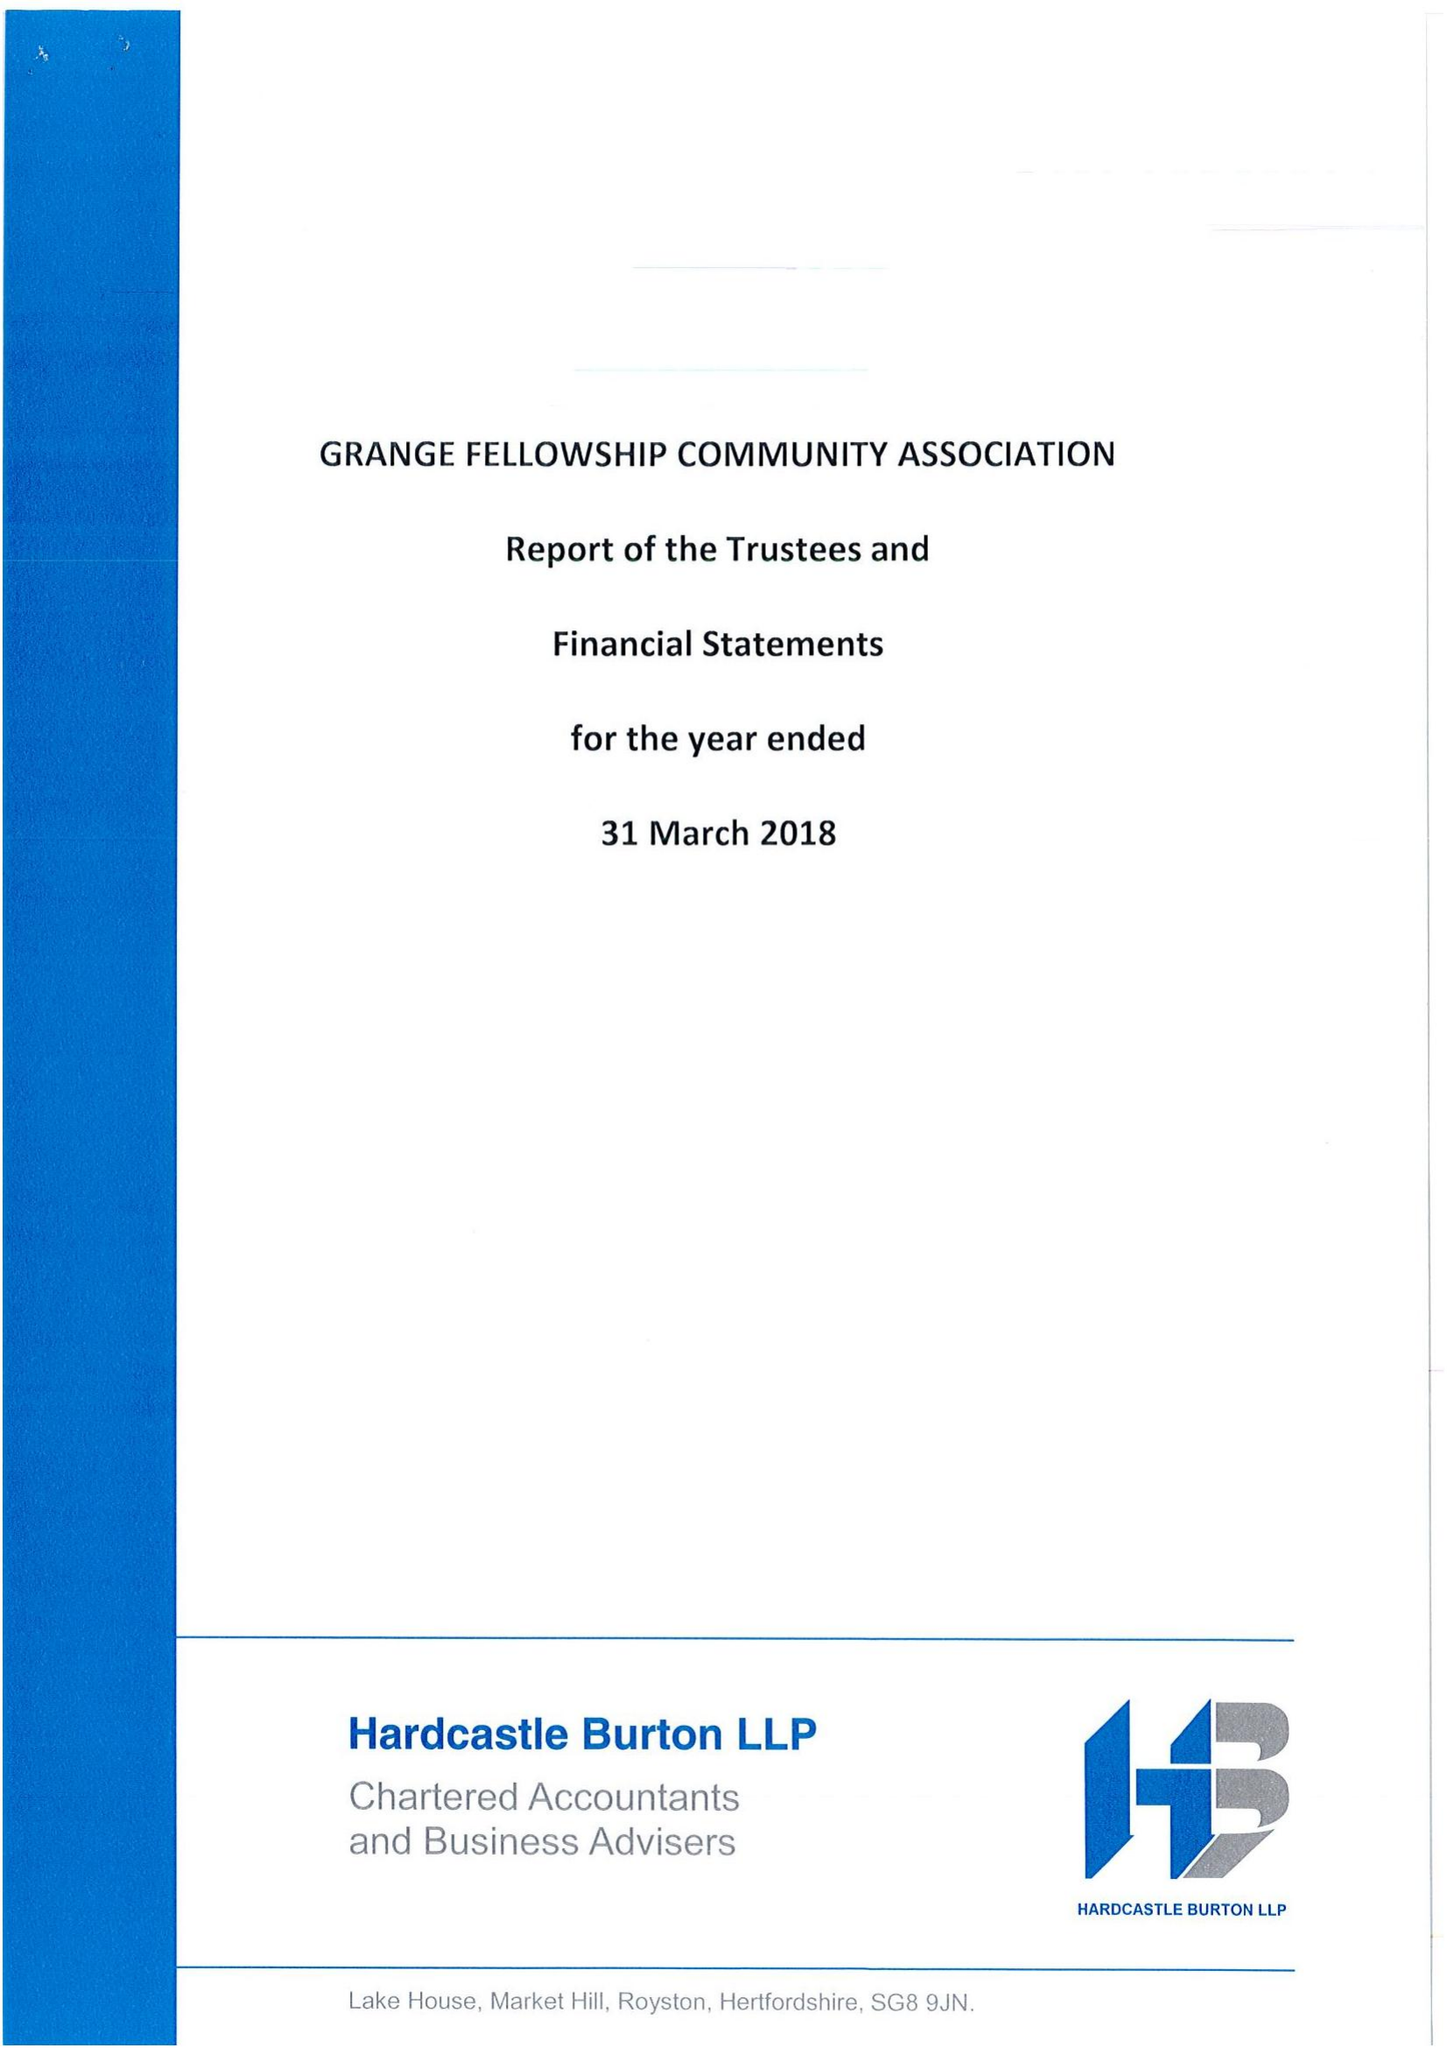What is the value for the address__street_line?
Answer the question using a single word or phrase. MIDDLEFIELDS 